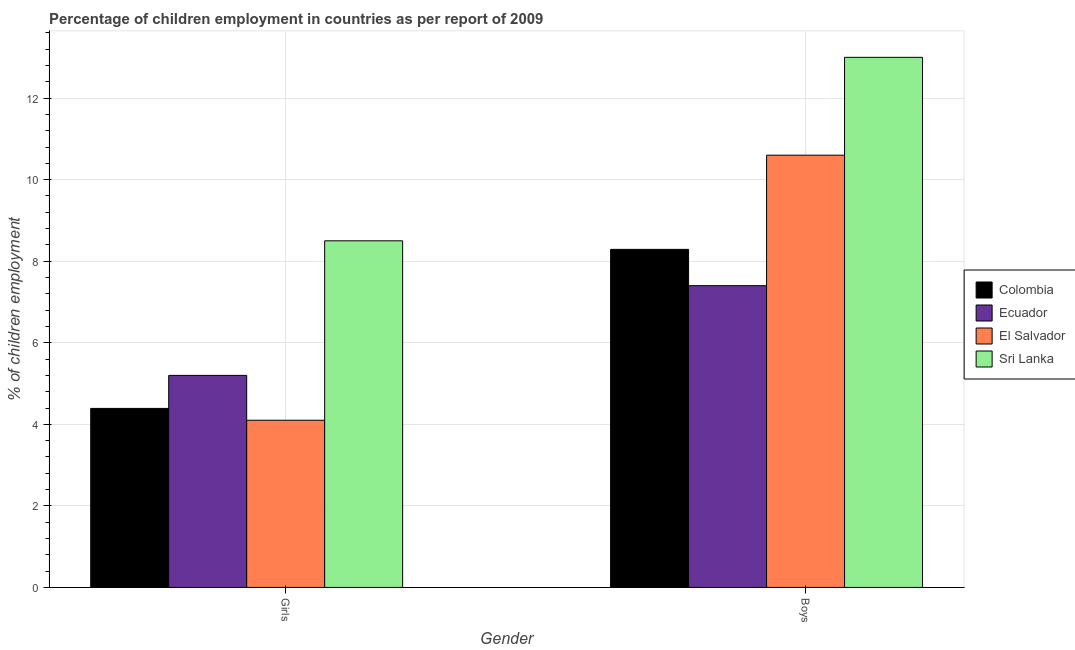Are the number of bars per tick equal to the number of legend labels?
Your answer should be compact. Yes. Are the number of bars on each tick of the X-axis equal?
Provide a succinct answer. Yes. What is the label of the 1st group of bars from the left?
Your answer should be very brief. Girls. What is the percentage of employed girls in Colombia?
Make the answer very short. 4.39. Across all countries, what is the maximum percentage of employed boys?
Keep it short and to the point. 13. In which country was the percentage of employed girls maximum?
Keep it short and to the point. Sri Lanka. In which country was the percentage of employed girls minimum?
Offer a very short reply. El Salvador. What is the total percentage of employed girls in the graph?
Your response must be concise. 22.19. What is the difference between the percentage of employed boys in Colombia and that in Sri Lanka?
Ensure brevity in your answer.  -4.71. What is the difference between the percentage of employed boys in El Salvador and the percentage of employed girls in Colombia?
Provide a short and direct response. 6.21. What is the average percentage of employed girls per country?
Give a very brief answer. 5.55. In how many countries, is the percentage of employed boys greater than 12 %?
Your answer should be compact. 1. What is the ratio of the percentage of employed boys in Sri Lanka to that in El Salvador?
Provide a succinct answer. 1.23. In how many countries, is the percentage of employed girls greater than the average percentage of employed girls taken over all countries?
Offer a very short reply. 1. What does the 4th bar from the left in Girls represents?
Keep it short and to the point. Sri Lanka. What does the 1st bar from the right in Girls represents?
Your response must be concise. Sri Lanka. Are all the bars in the graph horizontal?
Give a very brief answer. No. How many countries are there in the graph?
Your answer should be compact. 4. Are the values on the major ticks of Y-axis written in scientific E-notation?
Offer a terse response. No. Does the graph contain any zero values?
Make the answer very short. No. How are the legend labels stacked?
Give a very brief answer. Vertical. What is the title of the graph?
Offer a terse response. Percentage of children employment in countries as per report of 2009. What is the label or title of the Y-axis?
Make the answer very short. % of children employment. What is the % of children employment in Colombia in Girls?
Offer a very short reply. 4.39. What is the % of children employment in El Salvador in Girls?
Offer a very short reply. 4.1. What is the % of children employment in Sri Lanka in Girls?
Your response must be concise. 8.5. What is the % of children employment in Colombia in Boys?
Your response must be concise. 8.29. What is the % of children employment of Ecuador in Boys?
Provide a short and direct response. 7.4. What is the % of children employment of El Salvador in Boys?
Give a very brief answer. 10.6. Across all Gender, what is the maximum % of children employment in Colombia?
Your answer should be compact. 8.29. Across all Gender, what is the maximum % of children employment of Ecuador?
Provide a short and direct response. 7.4. Across all Gender, what is the minimum % of children employment in Colombia?
Provide a succinct answer. 4.39. Across all Gender, what is the minimum % of children employment in El Salvador?
Offer a very short reply. 4.1. What is the total % of children employment of Colombia in the graph?
Offer a terse response. 12.68. What is the total % of children employment of Ecuador in the graph?
Keep it short and to the point. 12.6. What is the total % of children employment of El Salvador in the graph?
Offer a terse response. 14.7. What is the difference between the % of children employment in Colombia in Girls and that in Boys?
Offer a very short reply. -3.9. What is the difference between the % of children employment in El Salvador in Girls and that in Boys?
Offer a terse response. -6.5. What is the difference between the % of children employment of Colombia in Girls and the % of children employment of Ecuador in Boys?
Offer a very short reply. -3.01. What is the difference between the % of children employment in Colombia in Girls and the % of children employment in El Salvador in Boys?
Your response must be concise. -6.21. What is the difference between the % of children employment of Colombia in Girls and the % of children employment of Sri Lanka in Boys?
Your response must be concise. -8.61. What is the difference between the % of children employment in Ecuador in Girls and the % of children employment in El Salvador in Boys?
Make the answer very short. -5.4. What is the difference between the % of children employment in Ecuador in Girls and the % of children employment in Sri Lanka in Boys?
Your response must be concise. -7.8. What is the difference between the % of children employment of El Salvador in Girls and the % of children employment of Sri Lanka in Boys?
Provide a short and direct response. -8.9. What is the average % of children employment of Colombia per Gender?
Your response must be concise. 6.34. What is the average % of children employment of El Salvador per Gender?
Give a very brief answer. 7.35. What is the average % of children employment in Sri Lanka per Gender?
Keep it short and to the point. 10.75. What is the difference between the % of children employment in Colombia and % of children employment in Ecuador in Girls?
Provide a short and direct response. -0.81. What is the difference between the % of children employment of Colombia and % of children employment of El Salvador in Girls?
Offer a very short reply. 0.29. What is the difference between the % of children employment of Colombia and % of children employment of Sri Lanka in Girls?
Provide a succinct answer. -4.11. What is the difference between the % of children employment of Ecuador and % of children employment of El Salvador in Girls?
Your answer should be compact. 1.1. What is the difference between the % of children employment in Ecuador and % of children employment in Sri Lanka in Girls?
Make the answer very short. -3.3. What is the difference between the % of children employment in Colombia and % of children employment in Ecuador in Boys?
Provide a succinct answer. 0.89. What is the difference between the % of children employment in Colombia and % of children employment in El Salvador in Boys?
Offer a very short reply. -2.31. What is the difference between the % of children employment of Colombia and % of children employment of Sri Lanka in Boys?
Give a very brief answer. -4.71. What is the difference between the % of children employment of Ecuador and % of children employment of El Salvador in Boys?
Offer a very short reply. -3.2. What is the ratio of the % of children employment in Colombia in Girls to that in Boys?
Give a very brief answer. 0.53. What is the ratio of the % of children employment in Ecuador in Girls to that in Boys?
Make the answer very short. 0.7. What is the ratio of the % of children employment in El Salvador in Girls to that in Boys?
Make the answer very short. 0.39. What is the ratio of the % of children employment in Sri Lanka in Girls to that in Boys?
Provide a short and direct response. 0.65. What is the difference between the highest and the second highest % of children employment in Colombia?
Give a very brief answer. 3.9. What is the difference between the highest and the second highest % of children employment of Ecuador?
Your answer should be compact. 2.2. What is the difference between the highest and the second highest % of children employment of Sri Lanka?
Offer a very short reply. 4.5. What is the difference between the highest and the lowest % of children employment in Colombia?
Keep it short and to the point. 3.9. What is the difference between the highest and the lowest % of children employment of Sri Lanka?
Keep it short and to the point. 4.5. 